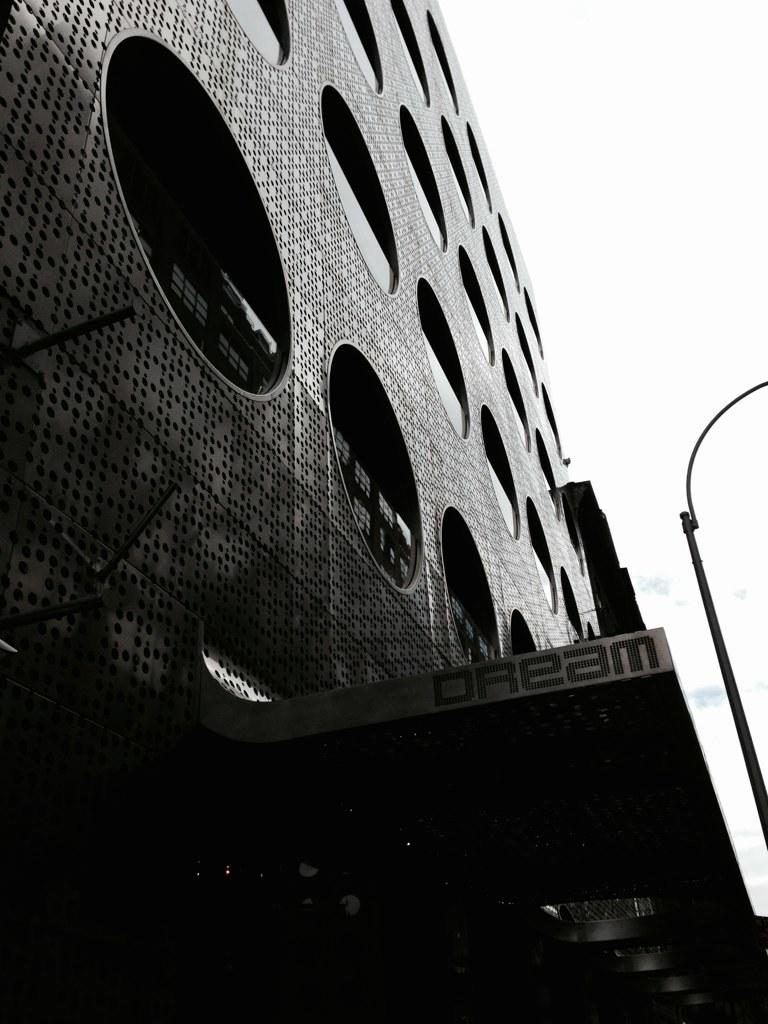What type of structure is present in the image? There is a building in the image. What feature can be observed on the building? The building has glass windows. What other object is visible in the image? There is a pole in the image. What is the color scheme of the image? The image is in black and white. Can you see any hands or a head in the image? No, there are no hands or a head visible in the image; it primarily features a building, glass windows, and a pole. 